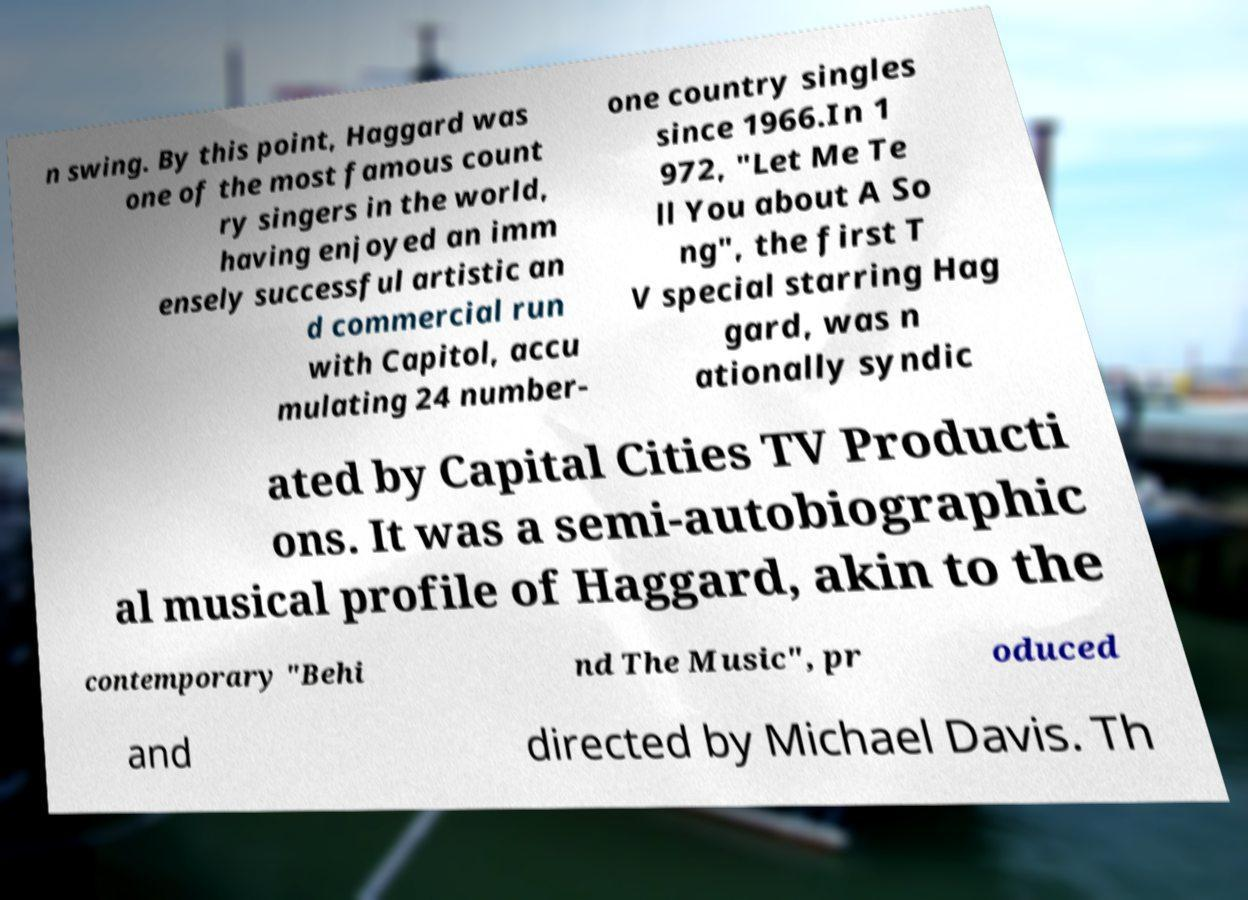Please read and relay the text visible in this image. What does it say? n swing. By this point, Haggard was one of the most famous count ry singers in the world, having enjoyed an imm ensely successful artistic an d commercial run with Capitol, accu mulating 24 number- one country singles since 1966.In 1 972, "Let Me Te ll You about A So ng", the first T V special starring Hag gard, was n ationally syndic ated by Capital Cities TV Producti ons. It was a semi-autobiographic al musical profile of Haggard, akin to the contemporary "Behi nd The Music", pr oduced and directed by Michael Davis. Th 